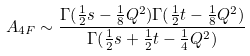<formula> <loc_0><loc_0><loc_500><loc_500>A _ { 4 F } \sim \frac { \Gamma ( \frac { 1 } { 2 } s - \frac { 1 } { 8 } Q ^ { 2 } ) \Gamma ( \frac { 1 } { 2 } t - \frac { 1 } { 8 } Q ^ { 2 } ) } { \Gamma ( \frac { 1 } { 2 } s + \frac { 1 } { 2 } t - \frac { 1 } { 4 } Q ^ { 2 } ) }</formula> 